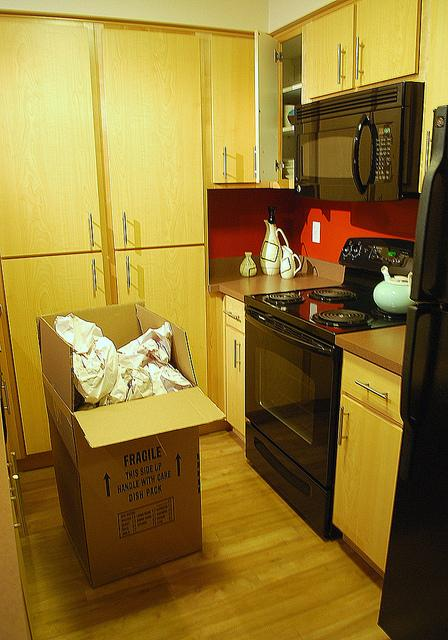What is the top word on the box? fragile 